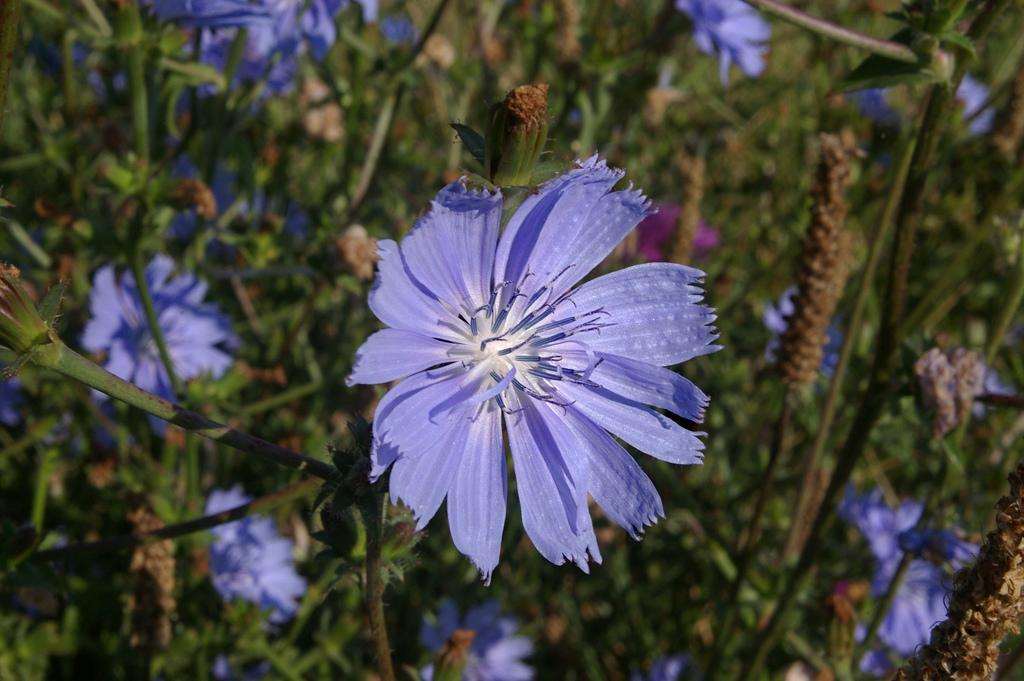What type of living organisms can be seen in the image? There are flowers and plants visible in the image. What colors are the flowers in the image? The flowers are in purple and pink colors. What color are the plants in the image? The plants are in green color. Can you see a man brushing his teeth near the sea in the image? There is no man or sea present in the image; it features flowers and plants. 